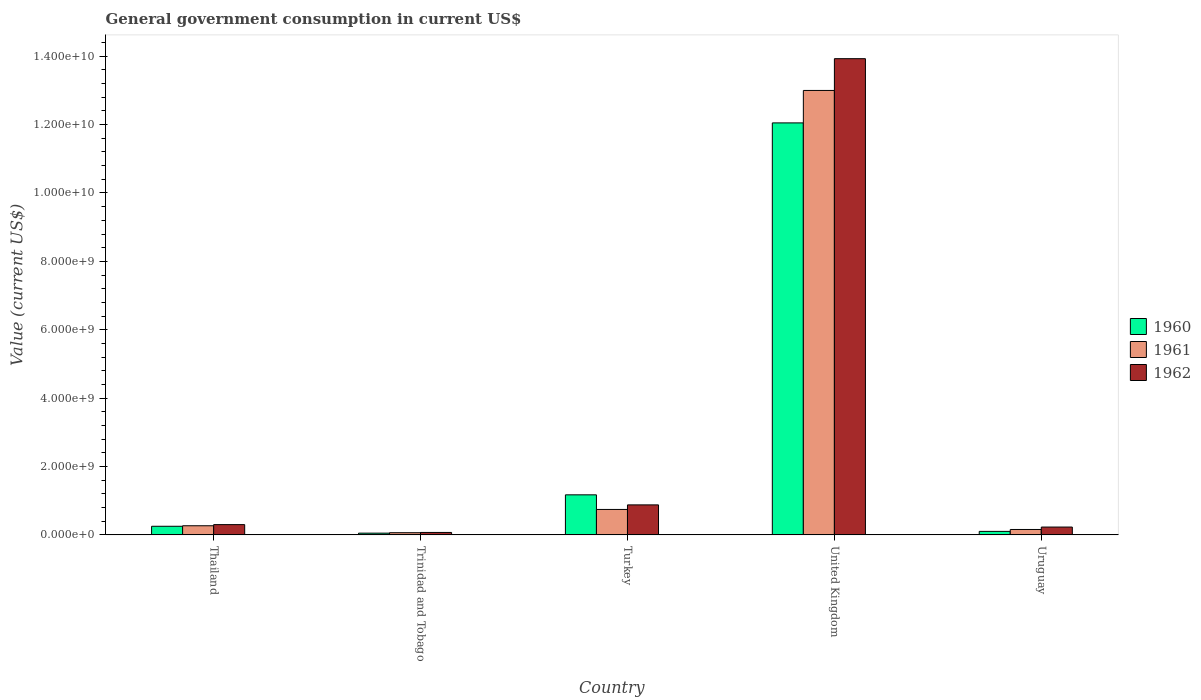How many different coloured bars are there?
Your answer should be compact. 3. Are the number of bars per tick equal to the number of legend labels?
Your response must be concise. Yes. Are the number of bars on each tick of the X-axis equal?
Offer a very short reply. Yes. What is the label of the 2nd group of bars from the left?
Offer a very short reply. Trinidad and Tobago. In how many cases, is the number of bars for a given country not equal to the number of legend labels?
Make the answer very short. 0. What is the government conusmption in 1960 in Trinidad and Tobago?
Keep it short and to the point. 5.12e+07. Across all countries, what is the maximum government conusmption in 1960?
Give a very brief answer. 1.20e+1. Across all countries, what is the minimum government conusmption in 1960?
Keep it short and to the point. 5.12e+07. In which country was the government conusmption in 1962 minimum?
Offer a terse response. Trinidad and Tobago. What is the total government conusmption in 1962 in the graph?
Make the answer very short. 1.54e+1. What is the difference between the government conusmption in 1962 in Thailand and that in Trinidad and Tobago?
Provide a succinct answer. 2.29e+08. What is the difference between the government conusmption in 1961 in Trinidad and Tobago and the government conusmption in 1960 in Turkey?
Ensure brevity in your answer.  -1.11e+09. What is the average government conusmption in 1960 per country?
Your response must be concise. 2.73e+09. What is the difference between the government conusmption of/in 1961 and government conusmption of/in 1962 in Thailand?
Keep it short and to the point. -3.36e+07. In how many countries, is the government conusmption in 1961 greater than 13600000000 US$?
Make the answer very short. 0. What is the ratio of the government conusmption in 1962 in Turkey to that in United Kingdom?
Your response must be concise. 0.06. Is the difference between the government conusmption in 1961 in Turkey and United Kingdom greater than the difference between the government conusmption in 1962 in Turkey and United Kingdom?
Your answer should be compact. Yes. What is the difference between the highest and the second highest government conusmption in 1960?
Keep it short and to the point. 9.19e+08. What is the difference between the highest and the lowest government conusmption in 1961?
Provide a succinct answer. 1.29e+1. In how many countries, is the government conusmption in 1962 greater than the average government conusmption in 1962 taken over all countries?
Provide a succinct answer. 1. What does the 2nd bar from the right in Trinidad and Tobago represents?
Make the answer very short. 1961. How many countries are there in the graph?
Give a very brief answer. 5. Are the values on the major ticks of Y-axis written in scientific E-notation?
Ensure brevity in your answer.  Yes. Where does the legend appear in the graph?
Your answer should be compact. Center right. What is the title of the graph?
Give a very brief answer. General government consumption in current US$. What is the label or title of the X-axis?
Ensure brevity in your answer.  Country. What is the label or title of the Y-axis?
Your answer should be compact. Value (current US$). What is the Value (current US$) in 1960 in Thailand?
Give a very brief answer. 2.52e+08. What is the Value (current US$) in 1961 in Thailand?
Give a very brief answer. 2.67e+08. What is the Value (current US$) in 1962 in Thailand?
Provide a short and direct response. 3.01e+08. What is the Value (current US$) in 1960 in Trinidad and Tobago?
Your response must be concise. 5.12e+07. What is the Value (current US$) of 1961 in Trinidad and Tobago?
Keep it short and to the point. 6.39e+07. What is the Value (current US$) in 1962 in Trinidad and Tobago?
Keep it short and to the point. 7.16e+07. What is the Value (current US$) of 1960 in Turkey?
Give a very brief answer. 1.17e+09. What is the Value (current US$) of 1961 in Turkey?
Provide a short and direct response. 7.44e+08. What is the Value (current US$) in 1962 in Turkey?
Your response must be concise. 8.78e+08. What is the Value (current US$) of 1960 in United Kingdom?
Provide a short and direct response. 1.20e+1. What is the Value (current US$) in 1961 in United Kingdom?
Your answer should be very brief. 1.30e+1. What is the Value (current US$) in 1962 in United Kingdom?
Provide a short and direct response. 1.39e+1. What is the Value (current US$) in 1960 in Uruguay?
Make the answer very short. 1.03e+08. What is the Value (current US$) in 1961 in Uruguay?
Give a very brief answer. 1.58e+08. What is the Value (current US$) of 1962 in Uruguay?
Offer a very short reply. 2.29e+08. Across all countries, what is the maximum Value (current US$) of 1960?
Your response must be concise. 1.20e+1. Across all countries, what is the maximum Value (current US$) of 1961?
Ensure brevity in your answer.  1.30e+1. Across all countries, what is the maximum Value (current US$) in 1962?
Your response must be concise. 1.39e+1. Across all countries, what is the minimum Value (current US$) of 1960?
Ensure brevity in your answer.  5.12e+07. Across all countries, what is the minimum Value (current US$) of 1961?
Give a very brief answer. 6.39e+07. Across all countries, what is the minimum Value (current US$) of 1962?
Ensure brevity in your answer.  7.16e+07. What is the total Value (current US$) of 1960 in the graph?
Provide a succinct answer. 1.36e+1. What is the total Value (current US$) in 1961 in the graph?
Provide a short and direct response. 1.42e+1. What is the total Value (current US$) in 1962 in the graph?
Offer a very short reply. 1.54e+1. What is the difference between the Value (current US$) of 1960 in Thailand and that in Trinidad and Tobago?
Keep it short and to the point. 2.01e+08. What is the difference between the Value (current US$) in 1961 in Thailand and that in Trinidad and Tobago?
Your response must be concise. 2.03e+08. What is the difference between the Value (current US$) in 1962 in Thailand and that in Trinidad and Tobago?
Keep it short and to the point. 2.29e+08. What is the difference between the Value (current US$) in 1960 in Thailand and that in Turkey?
Your answer should be compact. -9.19e+08. What is the difference between the Value (current US$) in 1961 in Thailand and that in Turkey?
Your answer should be very brief. -4.77e+08. What is the difference between the Value (current US$) of 1962 in Thailand and that in Turkey?
Your response must be concise. -5.77e+08. What is the difference between the Value (current US$) in 1960 in Thailand and that in United Kingdom?
Offer a very short reply. -1.18e+1. What is the difference between the Value (current US$) of 1961 in Thailand and that in United Kingdom?
Your answer should be very brief. -1.27e+1. What is the difference between the Value (current US$) in 1962 in Thailand and that in United Kingdom?
Offer a very short reply. -1.36e+1. What is the difference between the Value (current US$) in 1960 in Thailand and that in Uruguay?
Your response must be concise. 1.49e+08. What is the difference between the Value (current US$) of 1961 in Thailand and that in Uruguay?
Make the answer very short. 1.09e+08. What is the difference between the Value (current US$) in 1962 in Thailand and that in Uruguay?
Provide a succinct answer. 7.16e+07. What is the difference between the Value (current US$) of 1960 in Trinidad and Tobago and that in Turkey?
Offer a terse response. -1.12e+09. What is the difference between the Value (current US$) of 1961 in Trinidad and Tobago and that in Turkey?
Your response must be concise. -6.81e+08. What is the difference between the Value (current US$) of 1962 in Trinidad and Tobago and that in Turkey?
Your response must be concise. -8.06e+08. What is the difference between the Value (current US$) in 1960 in Trinidad and Tobago and that in United Kingdom?
Give a very brief answer. -1.20e+1. What is the difference between the Value (current US$) of 1961 in Trinidad and Tobago and that in United Kingdom?
Provide a succinct answer. -1.29e+1. What is the difference between the Value (current US$) of 1962 in Trinidad and Tobago and that in United Kingdom?
Offer a very short reply. -1.39e+1. What is the difference between the Value (current US$) of 1960 in Trinidad and Tobago and that in Uruguay?
Offer a terse response. -5.16e+07. What is the difference between the Value (current US$) in 1961 in Trinidad and Tobago and that in Uruguay?
Keep it short and to the point. -9.44e+07. What is the difference between the Value (current US$) of 1962 in Trinidad and Tobago and that in Uruguay?
Provide a short and direct response. -1.58e+08. What is the difference between the Value (current US$) of 1960 in Turkey and that in United Kingdom?
Ensure brevity in your answer.  -1.09e+1. What is the difference between the Value (current US$) in 1961 in Turkey and that in United Kingdom?
Provide a short and direct response. -1.23e+1. What is the difference between the Value (current US$) of 1962 in Turkey and that in United Kingdom?
Provide a succinct answer. -1.30e+1. What is the difference between the Value (current US$) of 1960 in Turkey and that in Uruguay?
Provide a short and direct response. 1.07e+09. What is the difference between the Value (current US$) in 1961 in Turkey and that in Uruguay?
Give a very brief answer. 5.86e+08. What is the difference between the Value (current US$) of 1962 in Turkey and that in Uruguay?
Provide a succinct answer. 6.49e+08. What is the difference between the Value (current US$) of 1960 in United Kingdom and that in Uruguay?
Provide a succinct answer. 1.19e+1. What is the difference between the Value (current US$) of 1961 in United Kingdom and that in Uruguay?
Provide a succinct answer. 1.28e+1. What is the difference between the Value (current US$) of 1962 in United Kingdom and that in Uruguay?
Provide a short and direct response. 1.37e+1. What is the difference between the Value (current US$) of 1960 in Thailand and the Value (current US$) of 1961 in Trinidad and Tobago?
Offer a terse response. 1.88e+08. What is the difference between the Value (current US$) in 1960 in Thailand and the Value (current US$) in 1962 in Trinidad and Tobago?
Your response must be concise. 1.81e+08. What is the difference between the Value (current US$) in 1961 in Thailand and the Value (current US$) in 1962 in Trinidad and Tobago?
Your answer should be very brief. 1.96e+08. What is the difference between the Value (current US$) in 1960 in Thailand and the Value (current US$) in 1961 in Turkey?
Ensure brevity in your answer.  -4.92e+08. What is the difference between the Value (current US$) in 1960 in Thailand and the Value (current US$) in 1962 in Turkey?
Give a very brief answer. -6.26e+08. What is the difference between the Value (current US$) of 1961 in Thailand and the Value (current US$) of 1962 in Turkey?
Your response must be concise. -6.11e+08. What is the difference between the Value (current US$) in 1960 in Thailand and the Value (current US$) in 1961 in United Kingdom?
Ensure brevity in your answer.  -1.27e+1. What is the difference between the Value (current US$) in 1960 in Thailand and the Value (current US$) in 1962 in United Kingdom?
Ensure brevity in your answer.  -1.37e+1. What is the difference between the Value (current US$) of 1961 in Thailand and the Value (current US$) of 1962 in United Kingdom?
Your answer should be compact. -1.37e+1. What is the difference between the Value (current US$) in 1960 in Thailand and the Value (current US$) in 1961 in Uruguay?
Keep it short and to the point. 9.39e+07. What is the difference between the Value (current US$) in 1960 in Thailand and the Value (current US$) in 1962 in Uruguay?
Give a very brief answer. 2.30e+07. What is the difference between the Value (current US$) of 1961 in Thailand and the Value (current US$) of 1962 in Uruguay?
Provide a succinct answer. 3.80e+07. What is the difference between the Value (current US$) in 1960 in Trinidad and Tobago and the Value (current US$) in 1961 in Turkey?
Offer a terse response. -6.93e+08. What is the difference between the Value (current US$) in 1960 in Trinidad and Tobago and the Value (current US$) in 1962 in Turkey?
Your response must be concise. -8.27e+08. What is the difference between the Value (current US$) of 1961 in Trinidad and Tobago and the Value (current US$) of 1962 in Turkey?
Ensure brevity in your answer.  -8.14e+08. What is the difference between the Value (current US$) of 1960 in Trinidad and Tobago and the Value (current US$) of 1961 in United Kingdom?
Give a very brief answer. -1.29e+1. What is the difference between the Value (current US$) of 1960 in Trinidad and Tobago and the Value (current US$) of 1962 in United Kingdom?
Provide a succinct answer. -1.39e+1. What is the difference between the Value (current US$) of 1961 in Trinidad and Tobago and the Value (current US$) of 1962 in United Kingdom?
Your response must be concise. -1.39e+1. What is the difference between the Value (current US$) in 1960 in Trinidad and Tobago and the Value (current US$) in 1961 in Uruguay?
Offer a very short reply. -1.07e+08. What is the difference between the Value (current US$) of 1960 in Trinidad and Tobago and the Value (current US$) of 1962 in Uruguay?
Offer a very short reply. -1.78e+08. What is the difference between the Value (current US$) in 1961 in Trinidad and Tobago and the Value (current US$) in 1962 in Uruguay?
Provide a succinct answer. -1.65e+08. What is the difference between the Value (current US$) in 1960 in Turkey and the Value (current US$) in 1961 in United Kingdom?
Offer a terse response. -1.18e+1. What is the difference between the Value (current US$) in 1960 in Turkey and the Value (current US$) in 1962 in United Kingdom?
Ensure brevity in your answer.  -1.28e+1. What is the difference between the Value (current US$) of 1961 in Turkey and the Value (current US$) of 1962 in United Kingdom?
Offer a very short reply. -1.32e+1. What is the difference between the Value (current US$) of 1960 in Turkey and the Value (current US$) of 1961 in Uruguay?
Your answer should be compact. 1.01e+09. What is the difference between the Value (current US$) in 1960 in Turkey and the Value (current US$) in 1962 in Uruguay?
Provide a short and direct response. 9.42e+08. What is the difference between the Value (current US$) of 1961 in Turkey and the Value (current US$) of 1962 in Uruguay?
Your response must be concise. 5.15e+08. What is the difference between the Value (current US$) in 1960 in United Kingdom and the Value (current US$) in 1961 in Uruguay?
Offer a terse response. 1.19e+1. What is the difference between the Value (current US$) in 1960 in United Kingdom and the Value (current US$) in 1962 in Uruguay?
Give a very brief answer. 1.18e+1. What is the difference between the Value (current US$) in 1961 in United Kingdom and the Value (current US$) in 1962 in Uruguay?
Give a very brief answer. 1.28e+1. What is the average Value (current US$) of 1960 per country?
Your response must be concise. 2.73e+09. What is the average Value (current US$) of 1961 per country?
Your answer should be very brief. 2.85e+09. What is the average Value (current US$) of 1962 per country?
Provide a succinct answer. 3.08e+09. What is the difference between the Value (current US$) of 1960 and Value (current US$) of 1961 in Thailand?
Your answer should be compact. -1.50e+07. What is the difference between the Value (current US$) of 1960 and Value (current US$) of 1962 in Thailand?
Keep it short and to the point. -4.86e+07. What is the difference between the Value (current US$) of 1961 and Value (current US$) of 1962 in Thailand?
Provide a succinct answer. -3.36e+07. What is the difference between the Value (current US$) of 1960 and Value (current US$) of 1961 in Trinidad and Tobago?
Make the answer very short. -1.27e+07. What is the difference between the Value (current US$) of 1960 and Value (current US$) of 1962 in Trinidad and Tobago?
Your answer should be compact. -2.04e+07. What is the difference between the Value (current US$) of 1961 and Value (current US$) of 1962 in Trinidad and Tobago?
Provide a succinct answer. -7.70e+06. What is the difference between the Value (current US$) of 1960 and Value (current US$) of 1961 in Turkey?
Keep it short and to the point. 4.27e+08. What is the difference between the Value (current US$) of 1960 and Value (current US$) of 1962 in Turkey?
Provide a succinct answer. 2.94e+08. What is the difference between the Value (current US$) in 1961 and Value (current US$) in 1962 in Turkey?
Your response must be concise. -1.33e+08. What is the difference between the Value (current US$) in 1960 and Value (current US$) in 1961 in United Kingdom?
Ensure brevity in your answer.  -9.49e+08. What is the difference between the Value (current US$) in 1960 and Value (current US$) in 1962 in United Kingdom?
Provide a succinct answer. -1.88e+09. What is the difference between the Value (current US$) in 1961 and Value (current US$) in 1962 in United Kingdom?
Keep it short and to the point. -9.29e+08. What is the difference between the Value (current US$) in 1960 and Value (current US$) in 1961 in Uruguay?
Your answer should be very brief. -5.54e+07. What is the difference between the Value (current US$) in 1960 and Value (current US$) in 1962 in Uruguay?
Keep it short and to the point. -1.26e+08. What is the difference between the Value (current US$) in 1961 and Value (current US$) in 1962 in Uruguay?
Your response must be concise. -7.09e+07. What is the ratio of the Value (current US$) in 1960 in Thailand to that in Trinidad and Tobago?
Ensure brevity in your answer.  4.92. What is the ratio of the Value (current US$) of 1961 in Thailand to that in Trinidad and Tobago?
Your answer should be compact. 4.18. What is the ratio of the Value (current US$) in 1962 in Thailand to that in Trinidad and Tobago?
Ensure brevity in your answer.  4.2. What is the ratio of the Value (current US$) of 1960 in Thailand to that in Turkey?
Provide a succinct answer. 0.22. What is the ratio of the Value (current US$) in 1961 in Thailand to that in Turkey?
Provide a succinct answer. 0.36. What is the ratio of the Value (current US$) in 1962 in Thailand to that in Turkey?
Keep it short and to the point. 0.34. What is the ratio of the Value (current US$) of 1960 in Thailand to that in United Kingdom?
Keep it short and to the point. 0.02. What is the ratio of the Value (current US$) of 1961 in Thailand to that in United Kingdom?
Provide a short and direct response. 0.02. What is the ratio of the Value (current US$) of 1962 in Thailand to that in United Kingdom?
Your answer should be compact. 0.02. What is the ratio of the Value (current US$) of 1960 in Thailand to that in Uruguay?
Your response must be concise. 2.45. What is the ratio of the Value (current US$) in 1961 in Thailand to that in Uruguay?
Keep it short and to the point. 1.69. What is the ratio of the Value (current US$) in 1962 in Thailand to that in Uruguay?
Your response must be concise. 1.31. What is the ratio of the Value (current US$) of 1960 in Trinidad and Tobago to that in Turkey?
Offer a very short reply. 0.04. What is the ratio of the Value (current US$) of 1961 in Trinidad and Tobago to that in Turkey?
Make the answer very short. 0.09. What is the ratio of the Value (current US$) in 1962 in Trinidad and Tobago to that in Turkey?
Give a very brief answer. 0.08. What is the ratio of the Value (current US$) of 1960 in Trinidad and Tobago to that in United Kingdom?
Provide a short and direct response. 0. What is the ratio of the Value (current US$) of 1961 in Trinidad and Tobago to that in United Kingdom?
Make the answer very short. 0. What is the ratio of the Value (current US$) of 1962 in Trinidad and Tobago to that in United Kingdom?
Ensure brevity in your answer.  0.01. What is the ratio of the Value (current US$) in 1960 in Trinidad and Tobago to that in Uruguay?
Your response must be concise. 0.5. What is the ratio of the Value (current US$) of 1961 in Trinidad and Tobago to that in Uruguay?
Give a very brief answer. 0.4. What is the ratio of the Value (current US$) of 1962 in Trinidad and Tobago to that in Uruguay?
Give a very brief answer. 0.31. What is the ratio of the Value (current US$) in 1960 in Turkey to that in United Kingdom?
Ensure brevity in your answer.  0.1. What is the ratio of the Value (current US$) in 1961 in Turkey to that in United Kingdom?
Provide a succinct answer. 0.06. What is the ratio of the Value (current US$) in 1962 in Turkey to that in United Kingdom?
Offer a very short reply. 0.06. What is the ratio of the Value (current US$) of 1960 in Turkey to that in Uruguay?
Keep it short and to the point. 11.39. What is the ratio of the Value (current US$) of 1961 in Turkey to that in Uruguay?
Offer a very short reply. 4.7. What is the ratio of the Value (current US$) in 1962 in Turkey to that in Uruguay?
Provide a short and direct response. 3.83. What is the ratio of the Value (current US$) of 1960 in United Kingdom to that in Uruguay?
Your response must be concise. 117.2. What is the ratio of the Value (current US$) of 1961 in United Kingdom to that in Uruguay?
Ensure brevity in your answer.  82.14. What is the ratio of the Value (current US$) of 1962 in United Kingdom to that in Uruguay?
Offer a terse response. 60.77. What is the difference between the highest and the second highest Value (current US$) of 1960?
Provide a succinct answer. 1.09e+1. What is the difference between the highest and the second highest Value (current US$) in 1961?
Your response must be concise. 1.23e+1. What is the difference between the highest and the second highest Value (current US$) of 1962?
Your answer should be compact. 1.30e+1. What is the difference between the highest and the lowest Value (current US$) in 1960?
Provide a short and direct response. 1.20e+1. What is the difference between the highest and the lowest Value (current US$) of 1961?
Your answer should be very brief. 1.29e+1. What is the difference between the highest and the lowest Value (current US$) of 1962?
Offer a very short reply. 1.39e+1. 